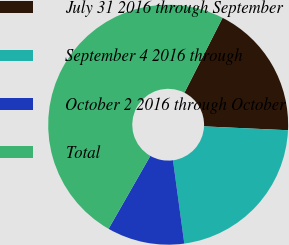Convert chart. <chart><loc_0><loc_0><loc_500><loc_500><pie_chart><fcel>July 31 2016 through September<fcel>September 4 2016 through<fcel>October 2 2016 through October<fcel>Total<nl><fcel>18.24%<fcel>22.12%<fcel>10.42%<fcel>49.22%<nl></chart> 